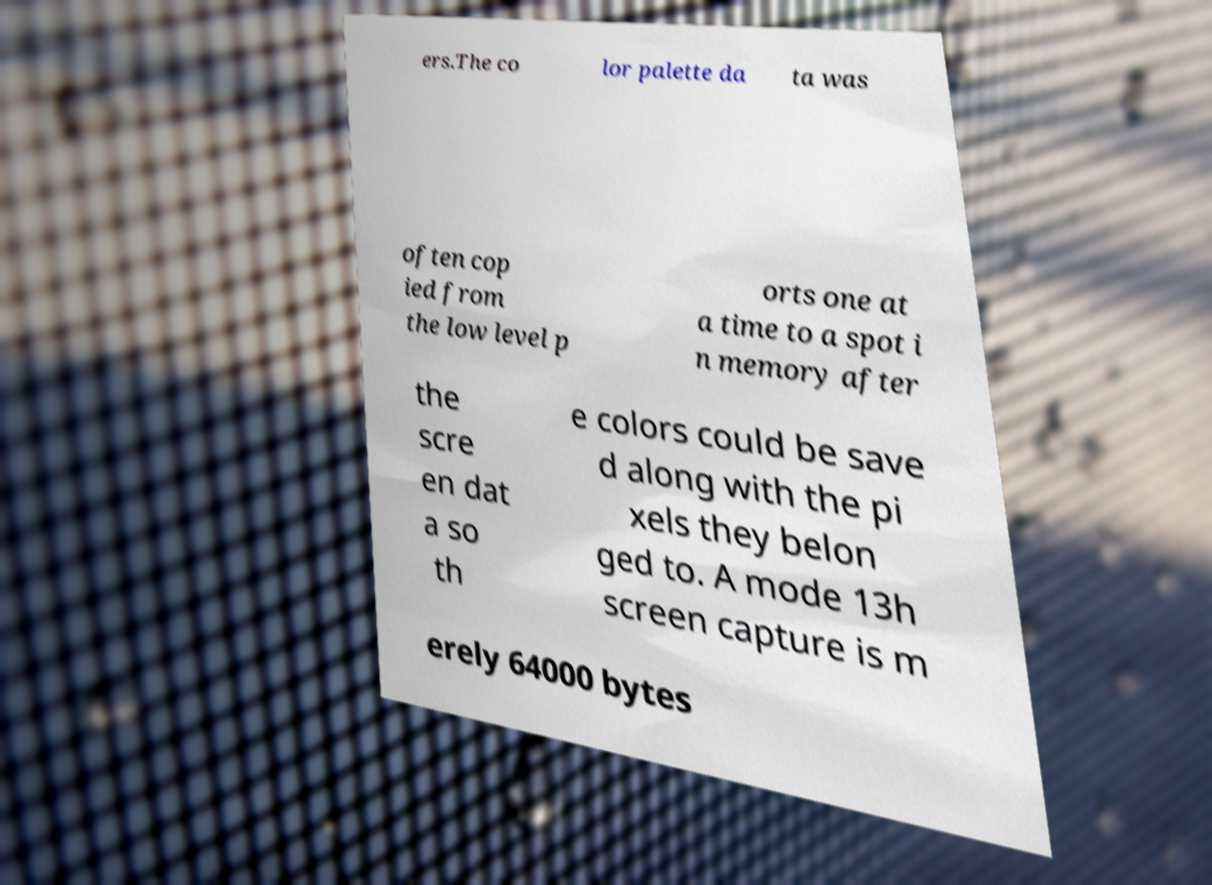Could you extract and type out the text from this image? ers.The co lor palette da ta was often cop ied from the low level p orts one at a time to a spot i n memory after the scre en dat a so th e colors could be save d along with the pi xels they belon ged to. A mode 13h screen capture is m erely 64000 bytes 